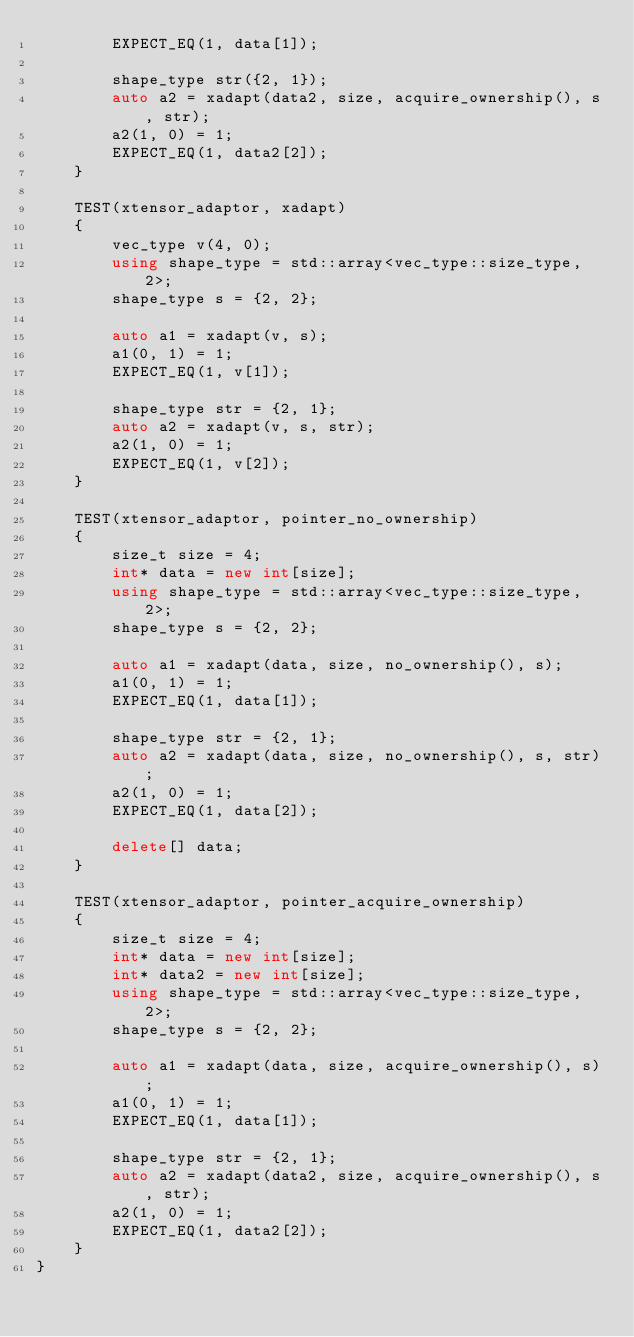Convert code to text. <code><loc_0><loc_0><loc_500><loc_500><_C++_>        EXPECT_EQ(1, data[1]);

        shape_type str({2, 1});
        auto a2 = xadapt(data2, size, acquire_ownership(), s, str);
        a2(1, 0) = 1;
        EXPECT_EQ(1, data2[2]);
    }

    TEST(xtensor_adaptor, xadapt)
    {
        vec_type v(4, 0);
        using shape_type = std::array<vec_type::size_type, 2>;
        shape_type s = {2, 2};

        auto a1 = xadapt(v, s);
        a1(0, 1) = 1;
        EXPECT_EQ(1, v[1]);

        shape_type str = {2, 1};
        auto a2 = xadapt(v, s, str);
        a2(1, 0) = 1;
        EXPECT_EQ(1, v[2]);
    }

    TEST(xtensor_adaptor, pointer_no_ownership)
    {
        size_t size = 4;
        int* data = new int[size];
        using shape_type = std::array<vec_type::size_type, 2>;
        shape_type s = {2, 2};

        auto a1 = xadapt(data, size, no_ownership(), s);
        a1(0, 1) = 1;
        EXPECT_EQ(1, data[1]);

        shape_type str = {2, 1};
        auto a2 = xadapt(data, size, no_ownership(), s, str);
        a2(1, 0) = 1;
        EXPECT_EQ(1, data[2]);

        delete[] data;
    }

    TEST(xtensor_adaptor, pointer_acquire_ownership)
    {
        size_t size = 4;
        int* data = new int[size];
        int* data2 = new int[size];
        using shape_type = std::array<vec_type::size_type, 2>;
        shape_type s = {2, 2};

        auto a1 = xadapt(data, size, acquire_ownership(), s);
        a1(0, 1) = 1;
        EXPECT_EQ(1, data[1]);

        shape_type str = {2, 1};
        auto a2 = xadapt(data2, size, acquire_ownership(), s, str);
        a2(1, 0) = 1;
        EXPECT_EQ(1, data2[2]);
    }
}
</code> 